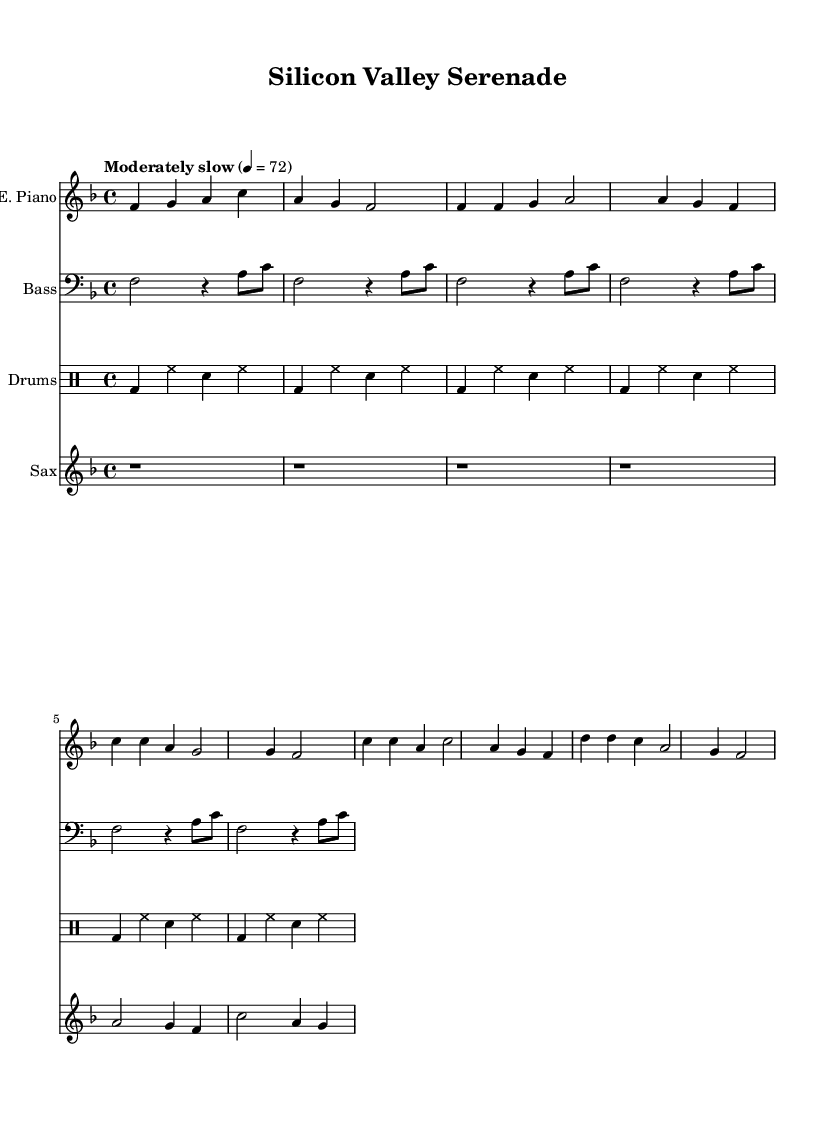What is the key signature of this music? The key signature is F major, which has one flat. This is indicated by the key signature at the beginning of the staff.
Answer: F major What is the time signature of this music? The time signature is 4/4, which can be seen in the notation at the beginning of the score. This indicates that there are four beats in each measure.
Answer: 4/4 What is the tempo marking for this piece? The tempo marking indicates "Moderately slow" with a metronome marking of 72 beats per minute. This is noted in the tempo instructions at the top of the score.
Answer: Moderately slow, 72 How many measures are there in the electric piano part? Counting the measures in the electric piano part shows there are a total of 8 measures in the provided section of music.
Answer: 8 What is the primary instrument used for the melody? The primary instrument playing the melody is the electric piano, as it has the main thematic material throughout the score.
Answer: Electric piano How many different instruments are included in this arrangement? There are four different instruments included: electric piano, bass, drums, and saxophone. This can be determined by the separate staves for each instrument in the score.
Answer: Four What type of groove does this piece represent? The piece represents a smooth soul groove, characterized by its laid-back rhythm and melodic lines that fit the soul genre. This is evident in the style of the written music.
Answer: Smooth soul groove 